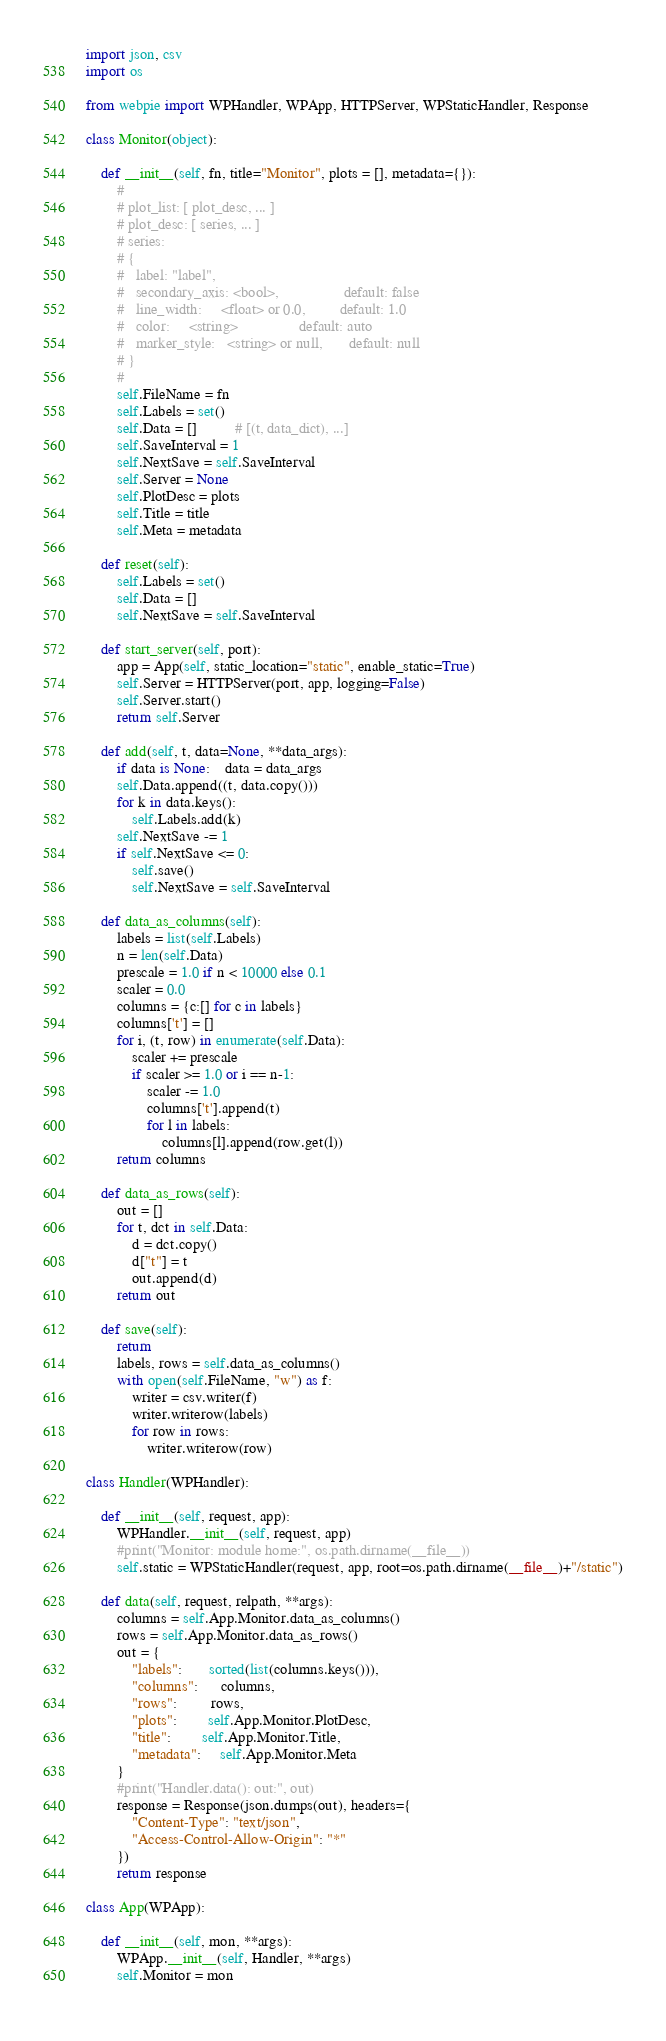<code> <loc_0><loc_0><loc_500><loc_500><_Python_>import json, csv
import os

from webpie import WPHandler, WPApp, HTTPServer, WPStaticHandler, Response

class Monitor(object):
    
    def __init__(self, fn, title="Monitor", plots = [], metadata={}):
        #
        # plot_list: [ plot_desc, ... ]
        # plot_desc: [ series, ... ]
        # series:
        # {
        #   label: "label",
        #   secondary_axis: <bool>,                 default: false
        #   line_width:     <float> or 0.0,         default: 1.0
        #   color:     <string>                default: auto
        #   marker_style:   <string> or null,       default: null
        # }
        #
        self.FileName = fn
        self.Labels = set()
        self.Data = []          # [(t, data_dict), ...]
        self.SaveInterval = 1
        self.NextSave = self.SaveInterval
        self.Server = None
        self.PlotDesc = plots
        self.Title = title
        self.Meta = metadata
        
    def reset(self):
        self.Labels = set()
        self.Data = []
        self.NextSave = self.SaveInterval        
        
    def start_server(self, port):
        app = App(self, static_location="static", enable_static=True)    
        self.Server = HTTPServer(port, app, logging=False)
        self.Server.start()
        return self.Server
        
    def add(self, t, data=None, **data_args):
        if data is None:    data = data_args
        self.Data.append((t, data.copy()))
        for k in data.keys():
            self.Labels.add(k)
        self.NextSave -= 1
        if self.NextSave <= 0:
            self.save()
            self.NextSave = self.SaveInterval

    def data_as_columns(self):
        labels = list(self.Labels)
        n = len(self.Data)
        prescale = 1.0 if n < 10000 else 0.1
        scaler = 0.0
        columns = {c:[] for c in labels}
        columns['t'] = []
        for i, (t, row) in enumerate(self.Data):
            scaler += prescale
            if scaler >= 1.0 or i == n-1:
                scaler -= 1.0
                columns['t'].append(t)
                for l in labels:
                    columns[l].append(row.get(l))
        return columns
        
    def data_as_rows(self):
        out = []
        for t, dct in self.Data:
            d = dct.copy()
            d["t"] = t
            out.append(d)
        return out
            
    def save(self):
        return
        labels, rows = self.data_as_columns()
        with open(self.FileName, "w") as f:
            writer = csv.writer(f)
            writer.writerow(labels)
            for row in rows:
                writer.writerow(row)

class Handler(WPHandler):
    
    def __init__(self, request, app):
        WPHandler.__init__(self, request, app)
        #print("Monitor: module home:", os.path.dirname(__file__))
        self.static = WPStaticHandler(request, app, root=os.path.dirname(__file__)+"/static")
    
    def data(self, request, relpath, **args):
        columns = self.App.Monitor.data_as_columns()
        rows = self.App.Monitor.data_as_rows()
        out = {
            "labels":       sorted(list(columns.keys())),
            "columns":      columns,
            "rows":         rows,
            "plots":        self.App.Monitor.PlotDesc,
            "title":        self.App.Monitor.Title,
            "metadata":     self.App.Monitor.Meta
        }
        #print("Handler.data(): out:", out)
        response = Response(json.dumps(out), headers={
            "Content-Type": "text/json",
            "Access-Control-Allow-Origin": "*"
        })
        return response
        
class App(WPApp):
    
    def __init__(self, mon, **args):
        WPApp.__init__(self, Handler, **args)
        self.Monitor = mon
        </code> 